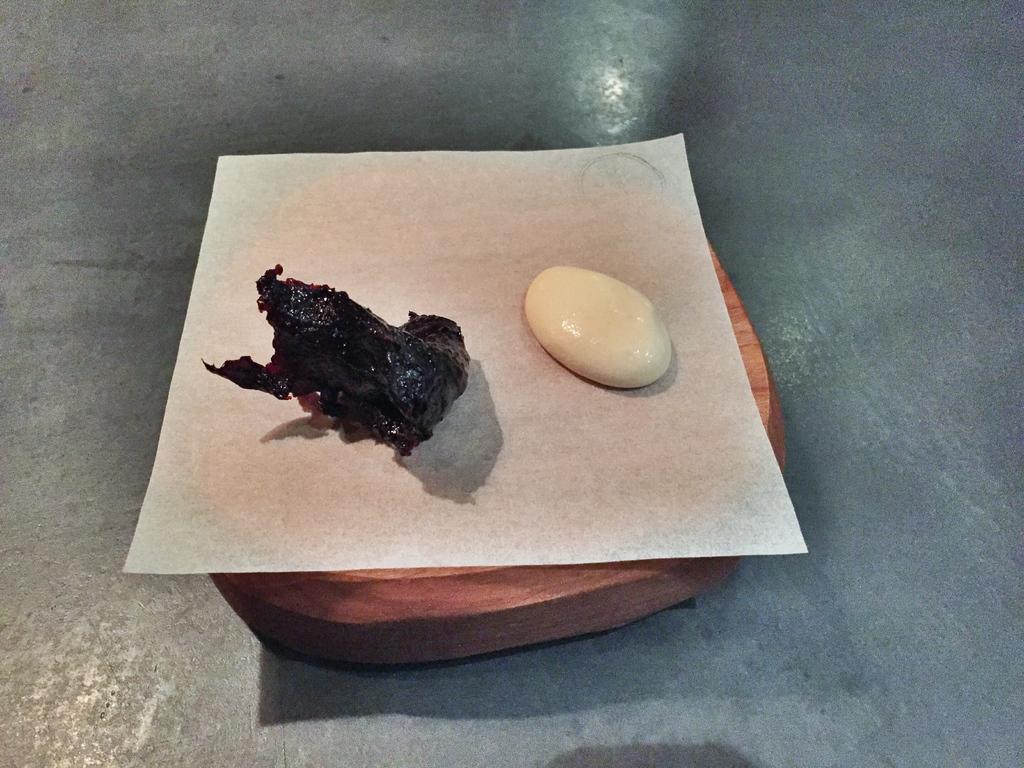In one or two sentences, can you explain what this image depicts? In this picture there are two objects placed on a white paper which is on a wooden object. 